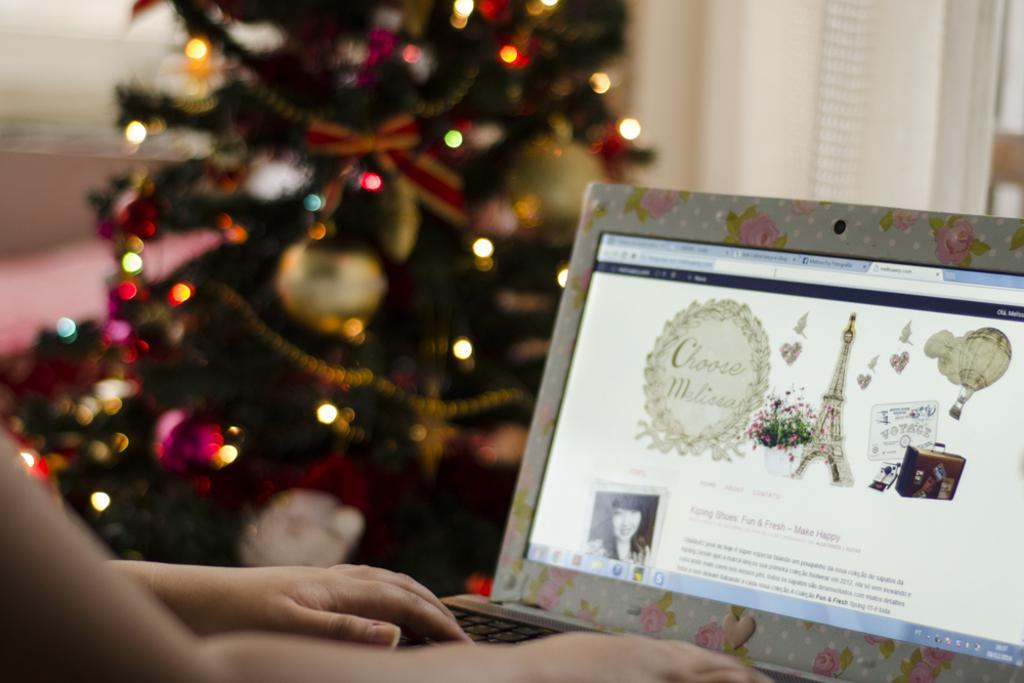In one or two sentences, can you explain what this image depicts? Here we can see hands of a person and there is a laptop. There is a blur background and we can see a Christmas tree. 